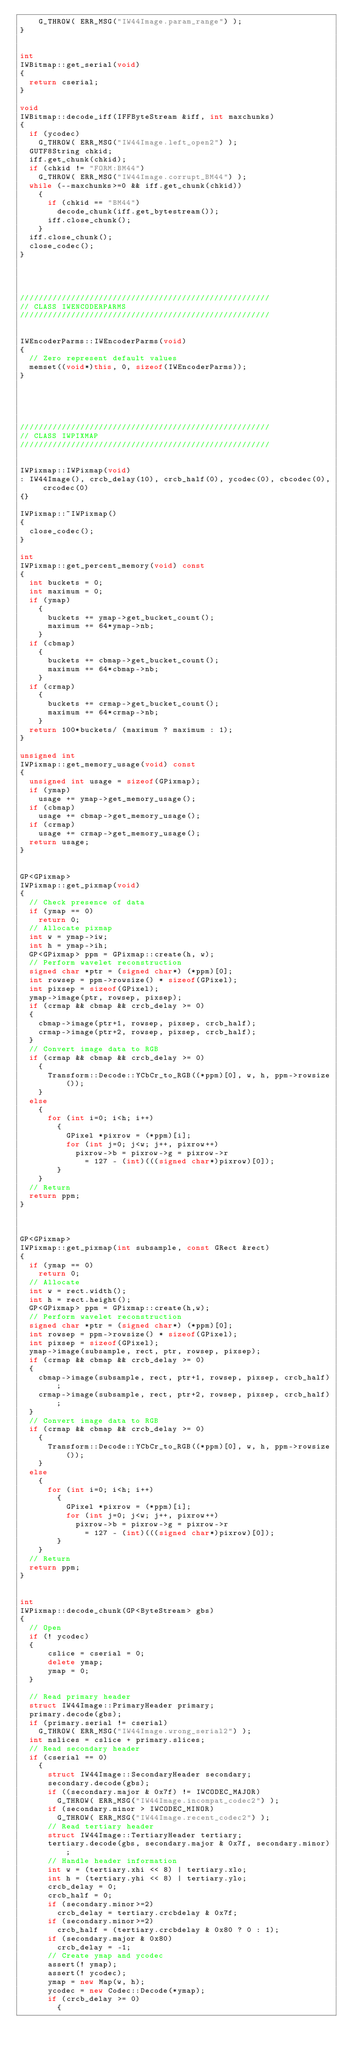<code> <loc_0><loc_0><loc_500><loc_500><_C++_>    G_THROW( ERR_MSG("IW44Image.param_range") );
}


int 
IWBitmap::get_serial(void)
{
  return cserial;
}

void 
IWBitmap::decode_iff(IFFByteStream &iff, int maxchunks)
{
  if (ycodec)
    G_THROW( ERR_MSG("IW44Image.left_open2") );
  GUTF8String chkid;
  iff.get_chunk(chkid);
  if (chkid != "FORM:BM44")
    G_THROW( ERR_MSG("IW44Image.corrupt_BM44") );
  while (--maxchunks>=0 && iff.get_chunk(chkid))
    {
      if (chkid == "BM44")
        decode_chunk(iff.get_bytestream());
      iff.close_chunk();
    }
  iff.close_chunk();
  close_codec();
}




//////////////////////////////////////////////////////
// CLASS IWENCODERPARMS
//////////////////////////////////////////////////////


IWEncoderParms::IWEncoderParms(void)
{
  // Zero represent default values
  memset((void*)this, 0, sizeof(IWEncoderParms));
}





//////////////////////////////////////////////////////
// CLASS IWPIXMAP
//////////////////////////////////////////////////////


IWPixmap::IWPixmap(void)
: IW44Image(), crcb_delay(10), crcb_half(0), ycodec(0), cbcodec(0), crcodec(0)
{}

IWPixmap::~IWPixmap()
{
  close_codec();
}

int
IWPixmap::get_percent_memory(void) const
{
  int buckets = 0;
  int maximum = 0;
  if (ymap)
    {
      buckets += ymap->get_bucket_count();
      maximum += 64*ymap->nb;
    }
  if (cbmap)
    {
      buckets += cbmap->get_bucket_count();
      maximum += 64*cbmap->nb;
    }
  if (crmap)
    {
      buckets += crmap->get_bucket_count();
      maximum += 64*crmap->nb;
    }
  return 100*buckets/ (maximum ? maximum : 1);
}

unsigned int
IWPixmap::get_memory_usage(void) const
{
  unsigned int usage = sizeof(GPixmap);
  if (ymap)
    usage += ymap->get_memory_usage();
  if (cbmap)
    usage += cbmap->get_memory_usage();
  if (crmap)
    usage += crmap->get_memory_usage();
  return usage;
}


GP<GPixmap> 
IWPixmap::get_pixmap(void)
{
  // Check presence of data
  if (ymap == 0)
    return 0;
  // Allocate pixmap
  int w = ymap->iw;
  int h = ymap->ih;
  GP<GPixmap> ppm = GPixmap::create(h, w);
  // Perform wavelet reconstruction
  signed char *ptr = (signed char*) (*ppm)[0];
  int rowsep = ppm->rowsize() * sizeof(GPixel);
  int pixsep = sizeof(GPixel);
  ymap->image(ptr, rowsep, pixsep);
  if (crmap && cbmap && crcb_delay >= 0)
  {
    cbmap->image(ptr+1, rowsep, pixsep, crcb_half);
    crmap->image(ptr+2, rowsep, pixsep, crcb_half);
  }
  // Convert image data to RGB
  if (crmap && cbmap && crcb_delay >= 0)
    {
      Transform::Decode::YCbCr_to_RGB((*ppm)[0], w, h, ppm->rowsize());
    }
  else
    {
      for (int i=0; i<h; i++)
        {
          GPixel *pixrow = (*ppm)[i];
          for (int j=0; j<w; j++, pixrow++)
            pixrow->b = pixrow->g = pixrow->r 
              = 127 - (int)(((signed char*)pixrow)[0]);
        }
    }
  // Return
  return ppm;
}



GP<GPixmap>
IWPixmap::get_pixmap(int subsample, const GRect &rect)
{
  if (ymap == 0)
    return 0;
  // Allocate
  int w = rect.width();
  int h = rect.height();
  GP<GPixmap> ppm = GPixmap::create(h,w);
  // Perform wavelet reconstruction
  signed char *ptr = (signed char*) (*ppm)[0];
  int rowsep = ppm->rowsize() * sizeof(GPixel);
  int pixsep = sizeof(GPixel);
  ymap->image(subsample, rect, ptr, rowsep, pixsep);
  if (crmap && cbmap && crcb_delay >= 0)
  {
    cbmap->image(subsample, rect, ptr+1, rowsep, pixsep, crcb_half);
    crmap->image(subsample, rect, ptr+2, rowsep, pixsep, crcb_half);
  }
  // Convert image data to RGB
  if (crmap && cbmap && crcb_delay >= 0)
    {
      Transform::Decode::YCbCr_to_RGB((*ppm)[0], w, h, ppm->rowsize());
    }
  else
    {
      for (int i=0; i<h; i++)
        {
          GPixel *pixrow = (*ppm)[i];
          for (int j=0; j<w; j++, pixrow++)
            pixrow->b = pixrow->g = pixrow->r 
              = 127 - (int)(((signed char*)pixrow)[0]);
        }
    }
  // Return
  return ppm;
}


int
IWPixmap::decode_chunk(GP<ByteStream> gbs)
{
  // Open
  if (! ycodec)
  {
      cslice = cserial = 0;
      delete ymap;
      ymap = 0;
  }

  // Read primary header
  struct IW44Image::PrimaryHeader primary;
  primary.decode(gbs);
  if (primary.serial != cserial)
    G_THROW( ERR_MSG("IW44Image.wrong_serial2") );
  int nslices = cslice + primary.slices;
  // Read secondary header
  if (cserial == 0)
    {
      struct IW44Image::SecondaryHeader secondary;
      secondary.decode(gbs);
      if ((secondary.major & 0x7f) != IWCODEC_MAJOR)
        G_THROW( ERR_MSG("IW44Image.incompat_codec2") );
      if (secondary.minor > IWCODEC_MINOR)
        G_THROW( ERR_MSG("IW44Image.recent_codec2") );
      // Read tertiary header
      struct IW44Image::TertiaryHeader tertiary;
      tertiary.decode(gbs, secondary.major & 0x7f, secondary.minor);
      // Handle header information
      int w = (tertiary.xhi << 8) | tertiary.xlo;
      int h = (tertiary.yhi << 8) | tertiary.ylo;
      crcb_delay = 0;
      crcb_half = 0;
      if (secondary.minor>=2)
        crcb_delay = tertiary.crcbdelay & 0x7f;
      if (secondary.minor>=2)
        crcb_half = (tertiary.crcbdelay & 0x80 ? 0 : 1);
      if (secondary.major & 0x80)
        crcb_delay = -1;
      // Create ymap and ycodec    
      assert(! ymap);
      assert(! ycodec);
      ymap = new Map(w, h);
      ycodec = new Codec::Decode(*ymap);
      if (crcb_delay >= 0)
        {</code> 